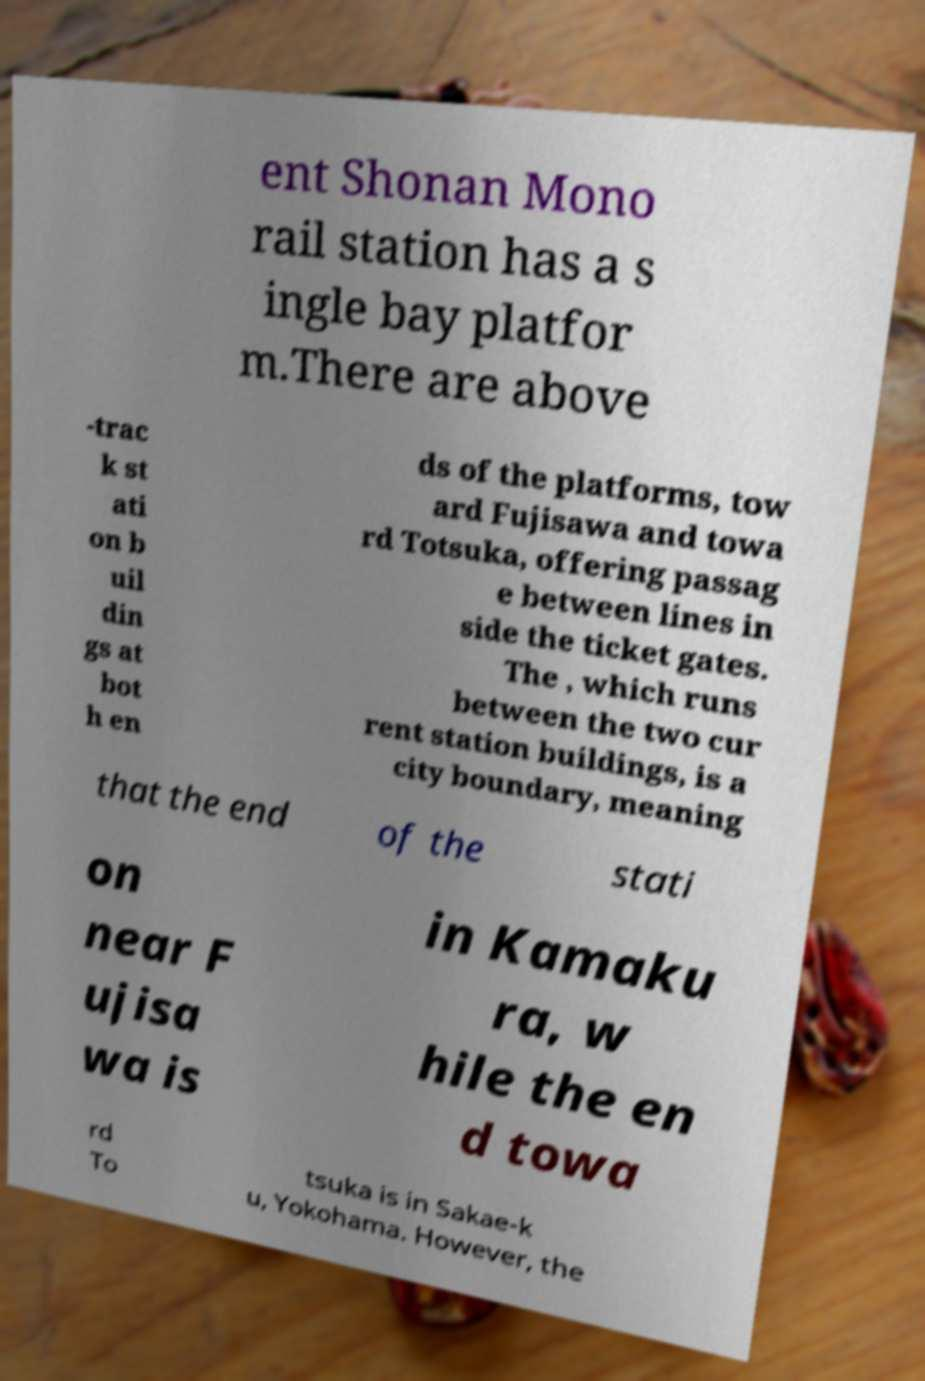For documentation purposes, I need the text within this image transcribed. Could you provide that? ent Shonan Mono rail station has a s ingle bay platfor m.There are above -trac k st ati on b uil din gs at bot h en ds of the platforms, tow ard Fujisawa and towa rd Totsuka, offering passag e between lines in side the ticket gates. The , which runs between the two cur rent station buildings, is a city boundary, meaning that the end of the stati on near F ujisa wa is in Kamaku ra, w hile the en d towa rd To tsuka is in Sakae-k u, Yokohama. However, the 